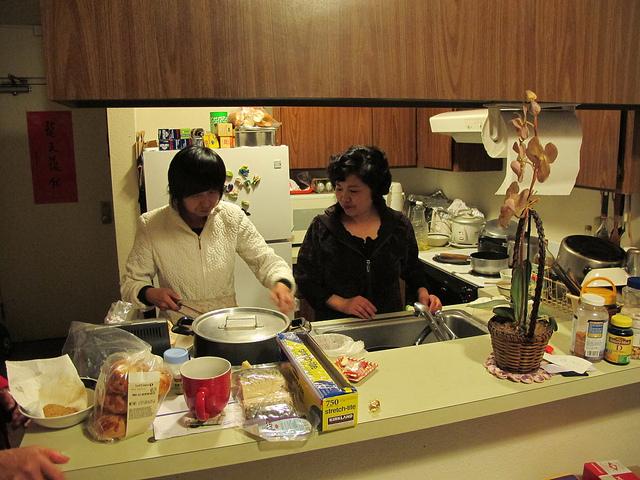How many friends?
Write a very short answer. 2. Are these people preparing food?
Short answer required. Yes. What food is being made?
Concise answer only. Not sure. What color is the woman's hair?
Write a very short answer. Black. Where are the people located?
Be succinct. Kitchen. What nationality are these people?
Short answer required. Chinese. 